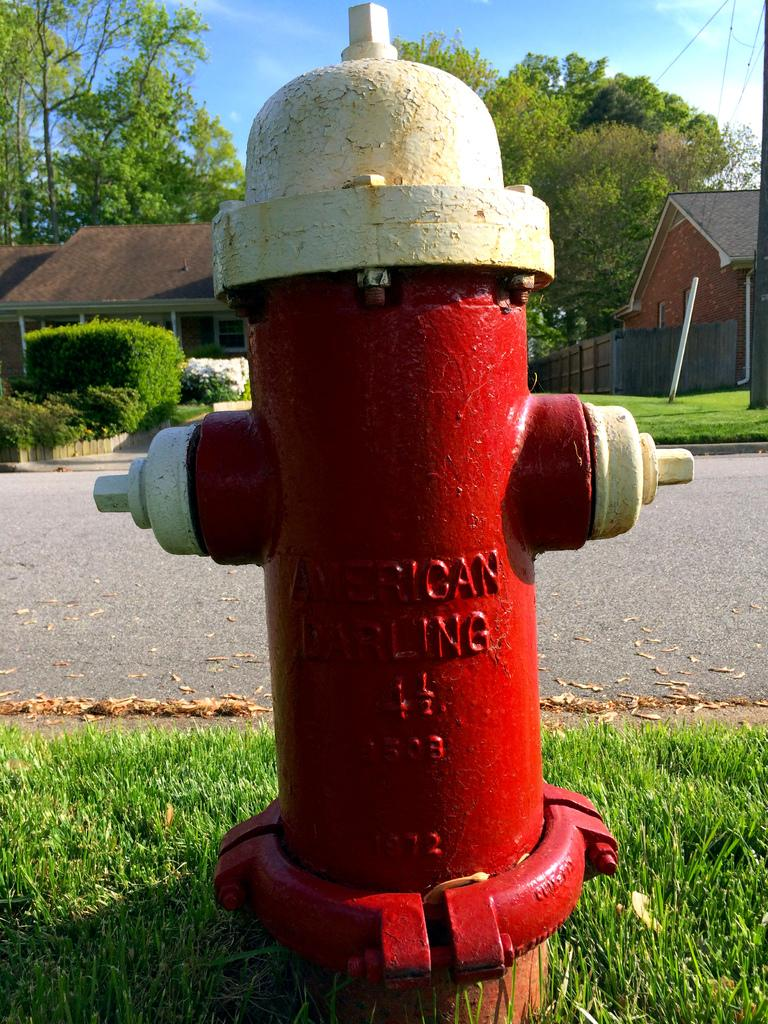What is the color of the stand pipe in the image? The stand pipe in the image is red. What can be seen on the stand pipe? Something is written on the stand pipe. What type of terrain is visible in the image? There is grass on the ground. What can be seen in the distance in the image? There is a road, buildings, trees, bushes, fencing, and the sky visible in the background. How many ducks are wearing boots in the image? There are no ducks or boots present in the image. 